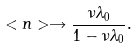<formula> <loc_0><loc_0><loc_500><loc_500>< n > \rightarrow \frac { \nu \lambda _ { 0 } } { 1 - \nu \lambda _ { 0 } } .</formula> 